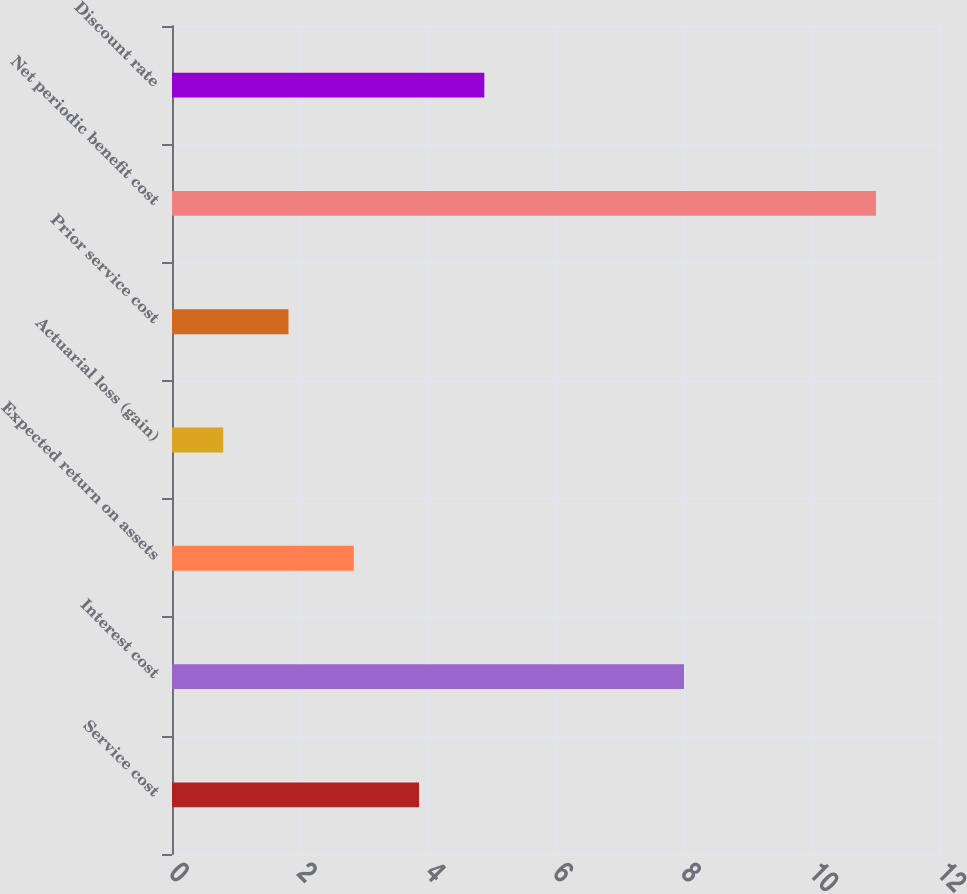Convert chart to OTSL. <chart><loc_0><loc_0><loc_500><loc_500><bar_chart><fcel>Service cost<fcel>Interest cost<fcel>Expected return on assets<fcel>Actuarial loss (gain)<fcel>Prior service cost<fcel>Net periodic benefit cost<fcel>Discount rate<nl><fcel>3.86<fcel>8<fcel>2.84<fcel>0.8<fcel>1.82<fcel>11<fcel>4.88<nl></chart> 